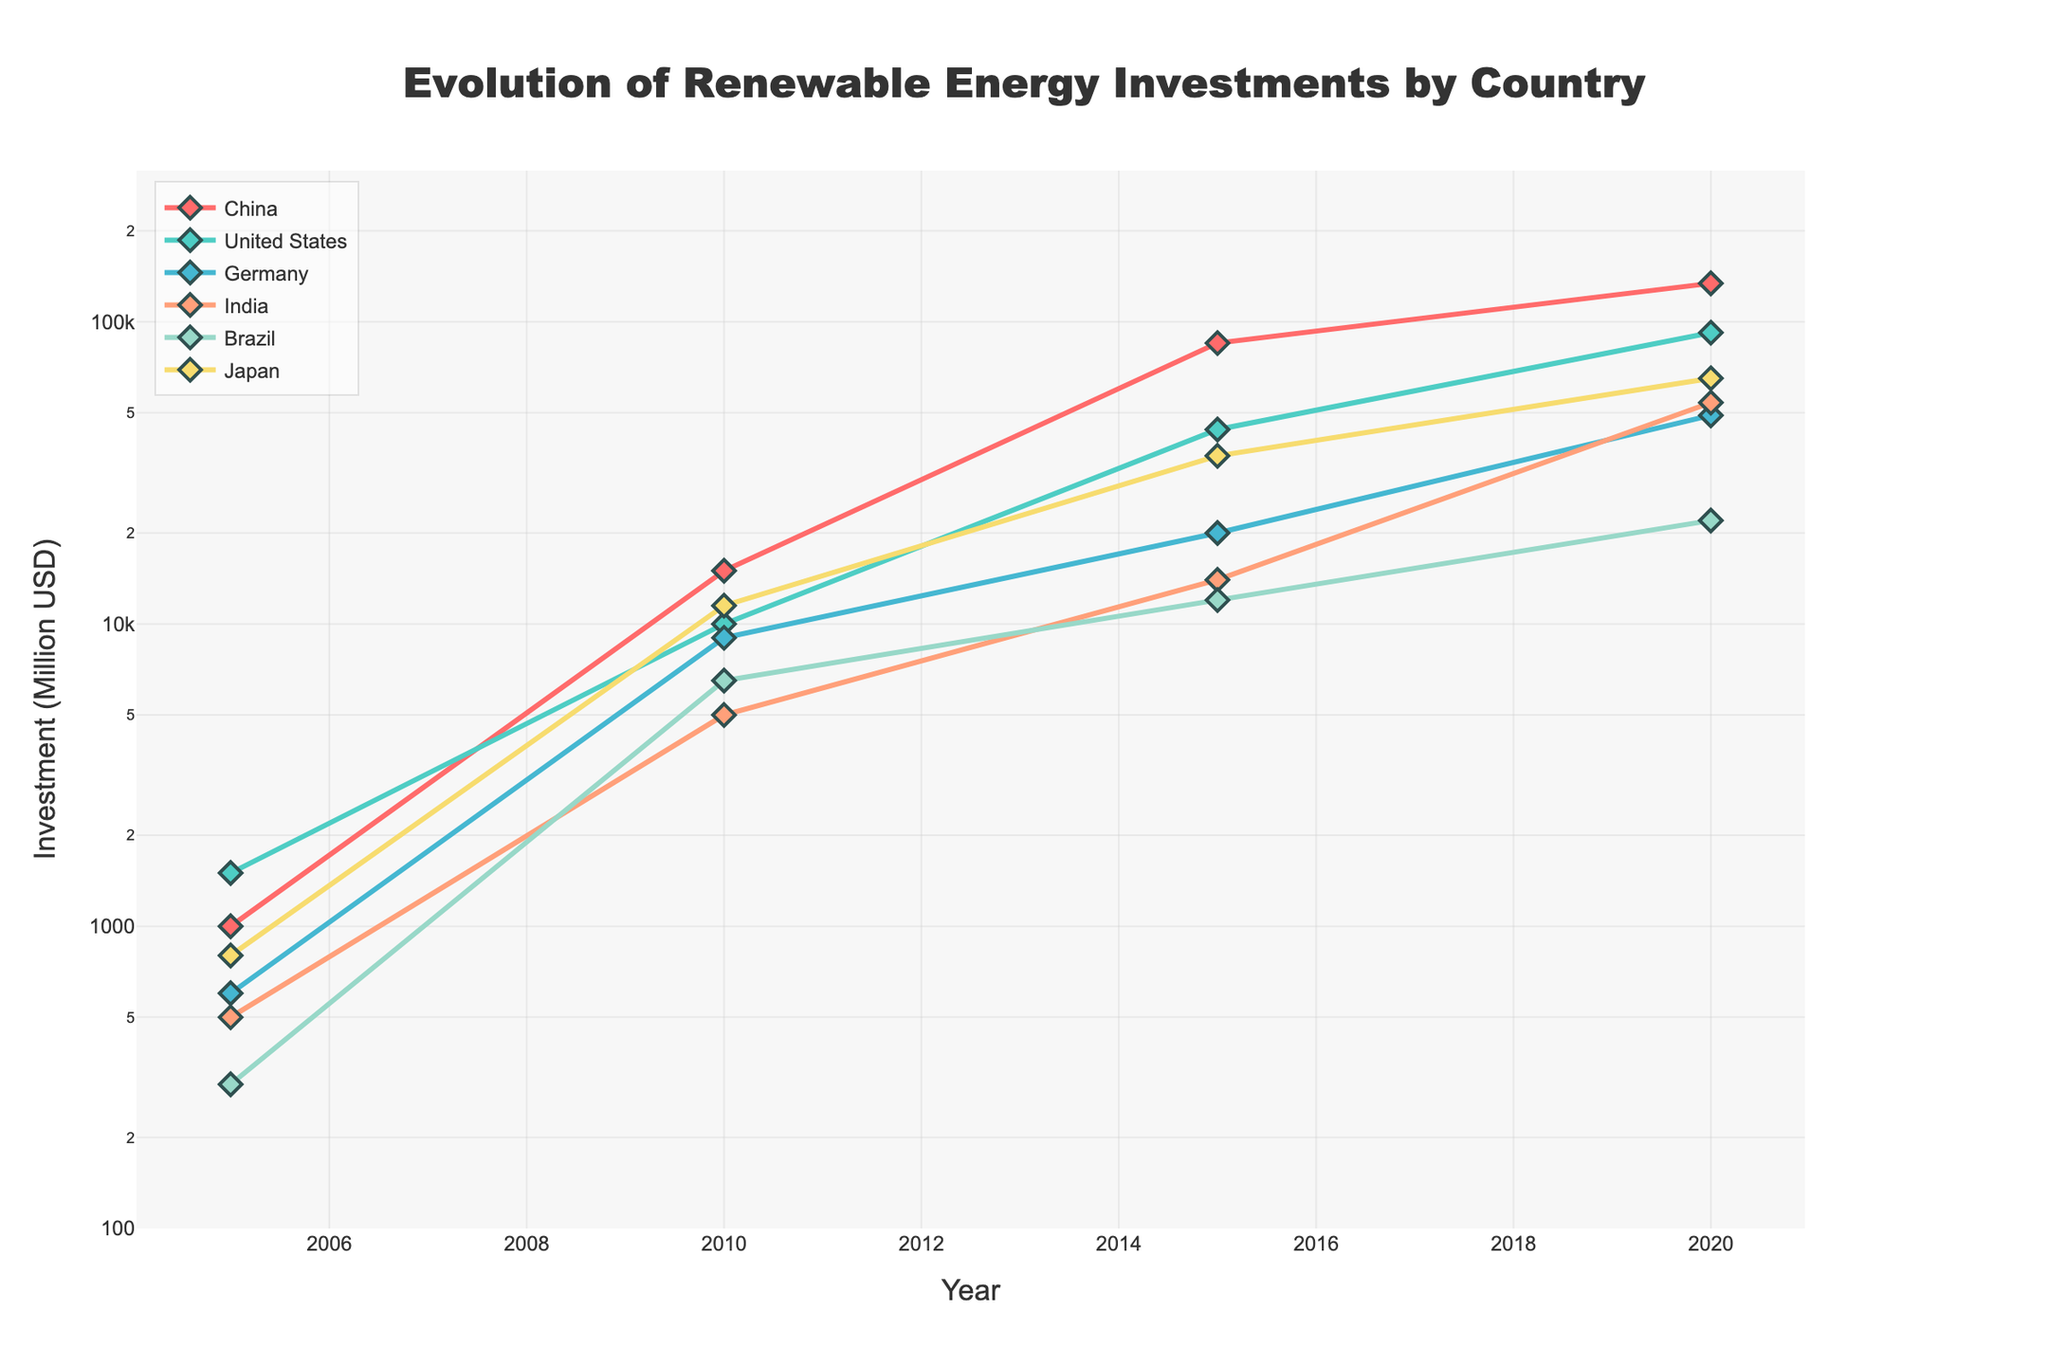What's the title of the figure? The title of the figure is always displayed prominently at the top. In this case, it should state the main topic of the plot.
Answer: Evolution of Renewable Energy Investments by Country Which country had the highest renewable energy investment in 2020? By comparing the y-values at the year 2020 for each line, the highest point indicates the highest investment. The China line reaches the highest point.
Answer: China What are the units used for the y-axis? The y-axis title provides the units for the y-values. According to the plot, the y-axis indicates monetary investments in millions of USD.
Answer: Million USD Which country had the smallest renewable energy investment in 2005? By looking at the points corresponding to the year 2005, the line with the lowest y-value represents the smallest investment. This is indicated by Brazil having the lowest starting point.
Answer: Brazil How did the investment in renewable energy for Japan change from 2015 to 2020? By comparing Japan's y-values for the years 2015 and 2020, determine the difference. Japan increased from around 36,000 million USD in 2015 to 65,000 million USD in 2020.
Answer: Increased Which country showed the largest increase in investment between 2005 and 2020? Calculate the difference in y-values for each country between 2005 and 2020 and identify the largest difference. China shows the largest difference, increasing from 1,000 to 134,000 million USD.
Answer: China What is the logarithmic range of the y-axis? Check the y-axis to see the range of values converted into logarithmic scale. It spans from around 10^2 to 10^5.5
Answer: 10^2 to 10^5.5 Compare the renewable energy investments in 2010 and 2015 for the United States. What trend do you observe? Examine the y-values for the United States in 2010 and 2015. The investment increases from 10,000 million USD in 2010 to 44,000 million USD in 2015, indicating a rising trend.
Answer: Rising trend Which country had a higher investment in 2015: Germany or Japan? Compare the y-values corresponding to the year 2015 for both Germany and Japan. Germany had an investment of around 20,000 million USD, while Japan had around 36,000 million USD. Japan had the higher investment.
Answer: Japan 